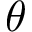<formula> <loc_0><loc_0><loc_500><loc_500>\theta</formula> 